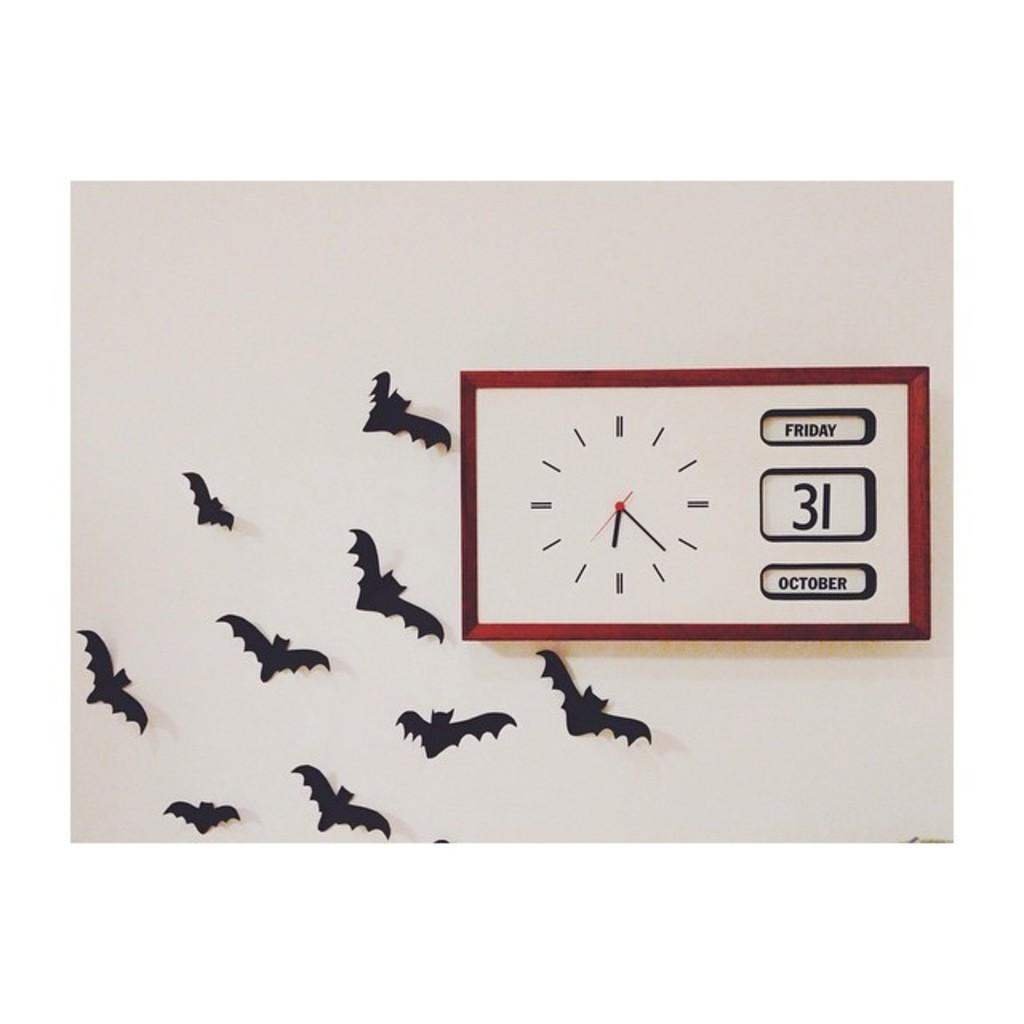<image>
Describe the image concisely. Plastic bats are on the wall beside a clock with the date of Friday October 31st on it. 